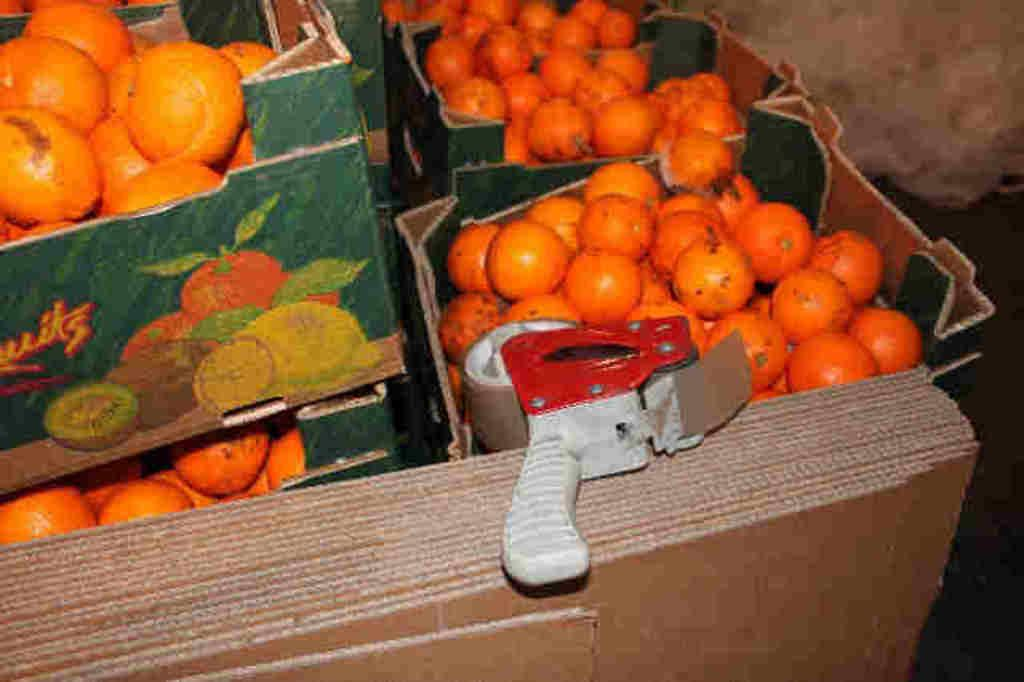What type of fruit is present in the image? There are many oranges in the image. How are the oranges stored in the image? The oranges are kept in a carton. What other object can be seen in the image? There is a plaster in the image. What type of equipment is visible in the image? There is a machine in the image. How many pears are visible on the edge of the carton in the image? There are no pears present in the image; it only contains oranges. 